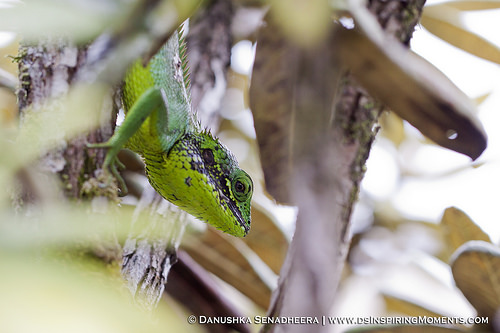<image>
Can you confirm if the gecko is on the tree? Yes. Looking at the image, I can see the gecko is positioned on top of the tree, with the tree providing support. 